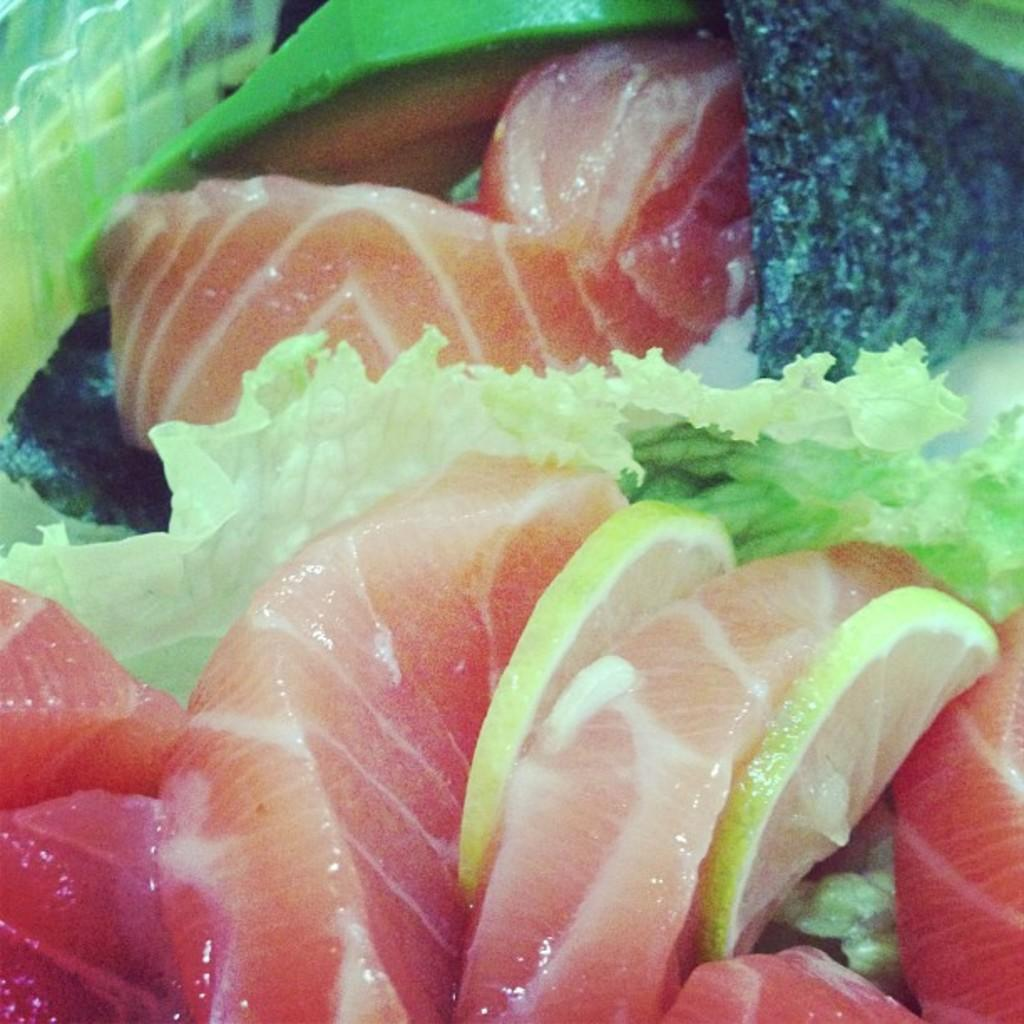What type of food can be seen in the image? There is food in the image, including meat and lemon slices. Can you describe the meat in the image? Yes, there is meat in the image. What additional ingredient is present in the image? There are lemon slices in the image. What type of loaf is being used to represent the feeling of happiness in the image? There is no loaf or representation of feelings in the image; it only features food, including meat and lemon slices. 